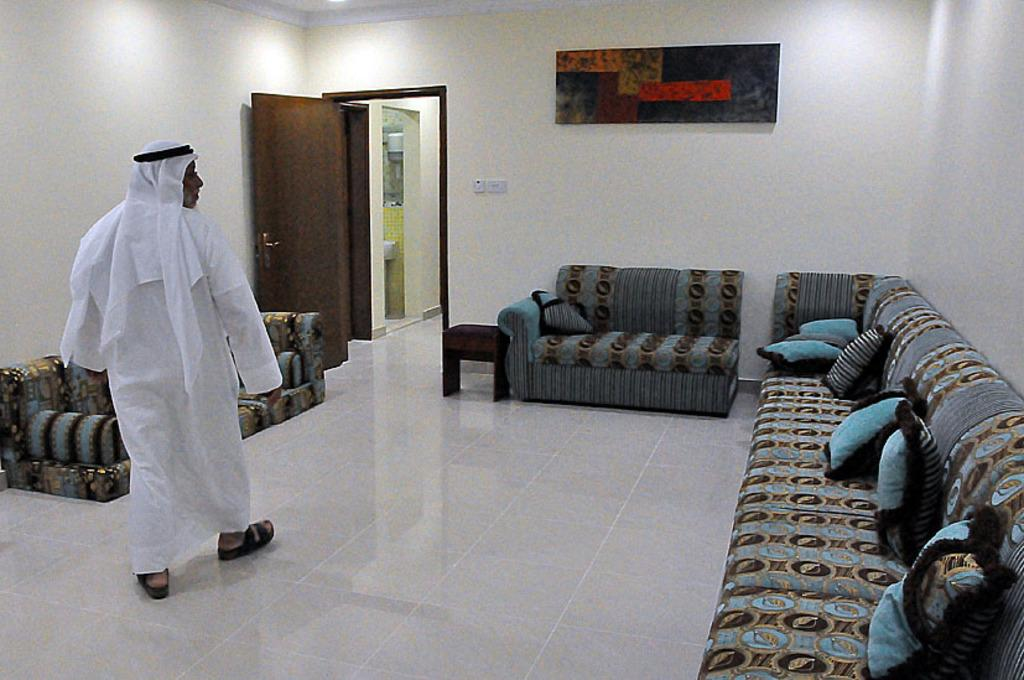What type of furniture is present in the room? There are sofas in the room. What is the person in the left part of the room doing? A person is walking in the left part of the room. What can be seen on the wall in the background? There is a painting in the background. What architectural feature is visible in the background? There is a door in the background. What language is the person speaking in the image? There is no indication of the person speaking in the image, so we cannot determine the language. What is the person's interest in the image? There is no information about the person's interests in the image. 